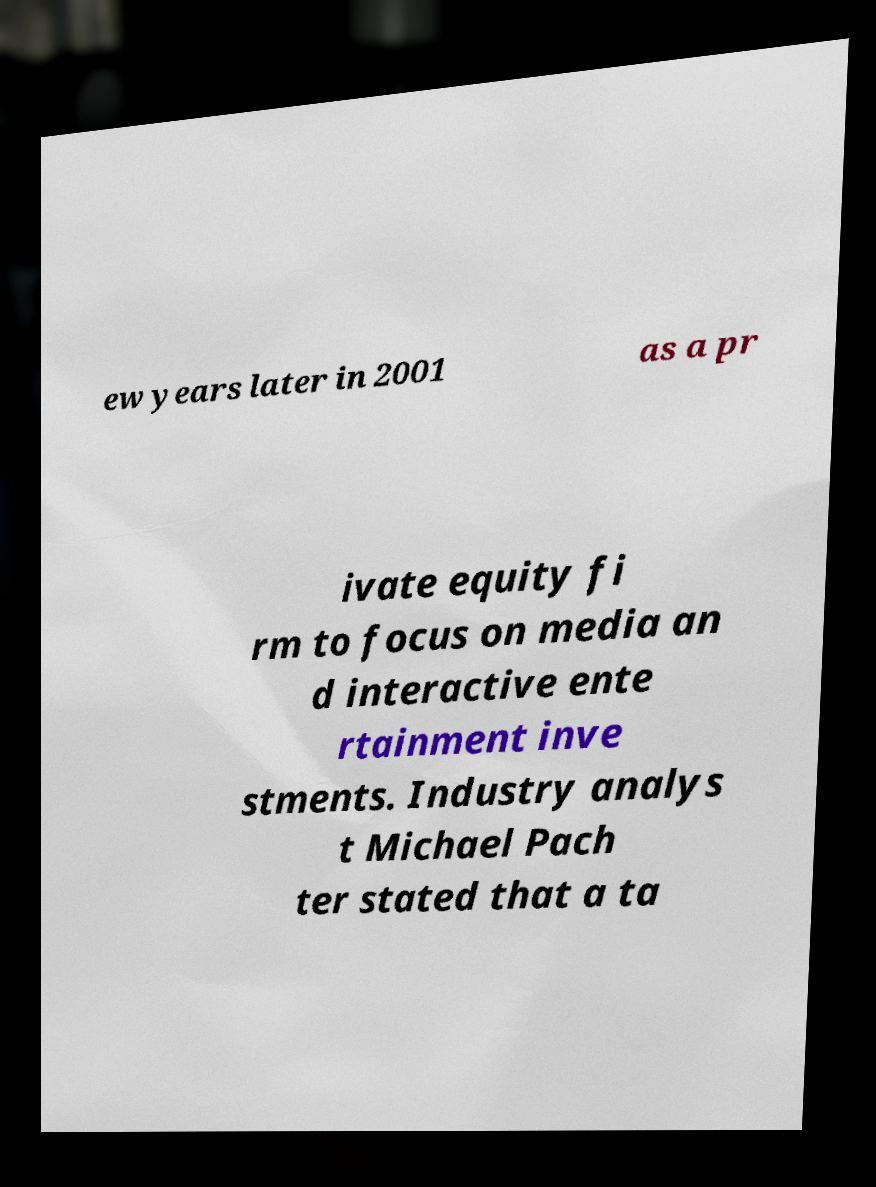What messages or text are displayed in this image? I need them in a readable, typed format. ew years later in 2001 as a pr ivate equity fi rm to focus on media an d interactive ente rtainment inve stments. Industry analys t Michael Pach ter stated that a ta 